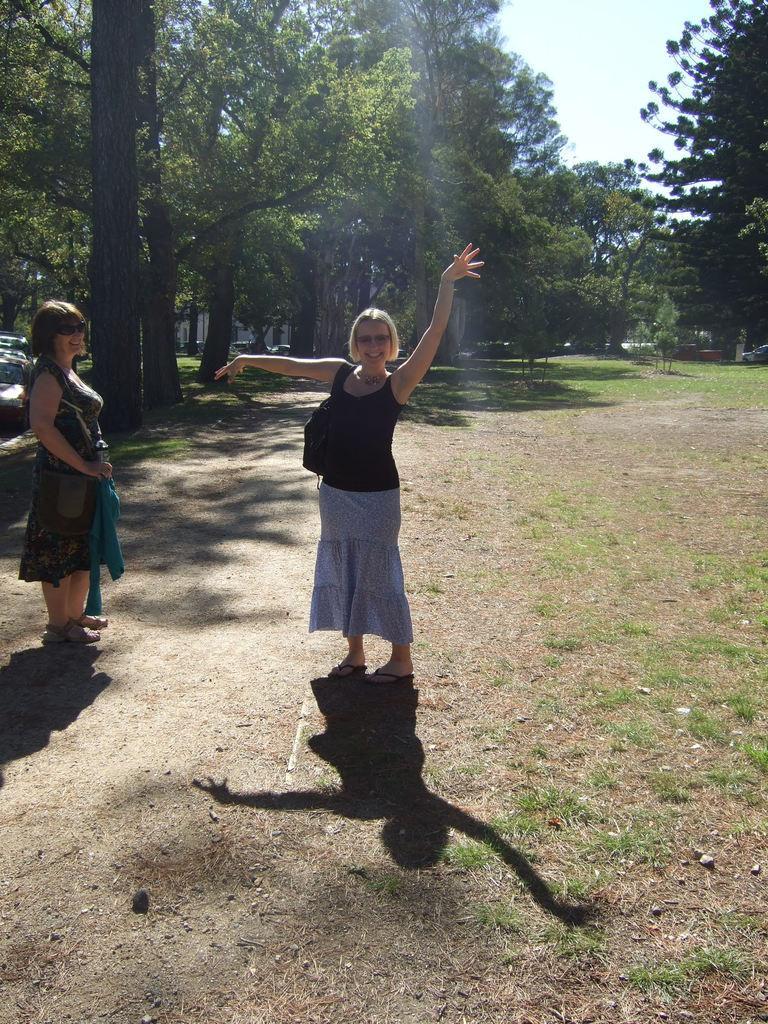How would you summarize this image in a sentence or two? At the left corner of the image there is a lady. Beside her in the middle of the ground there is a lady with black top is standing. In front of her on the ground there is a shadow. In the background there are many trees. 